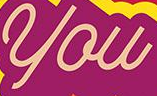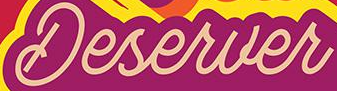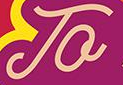What words are shown in these images in order, separated by a semicolon? you; Deserver; To 